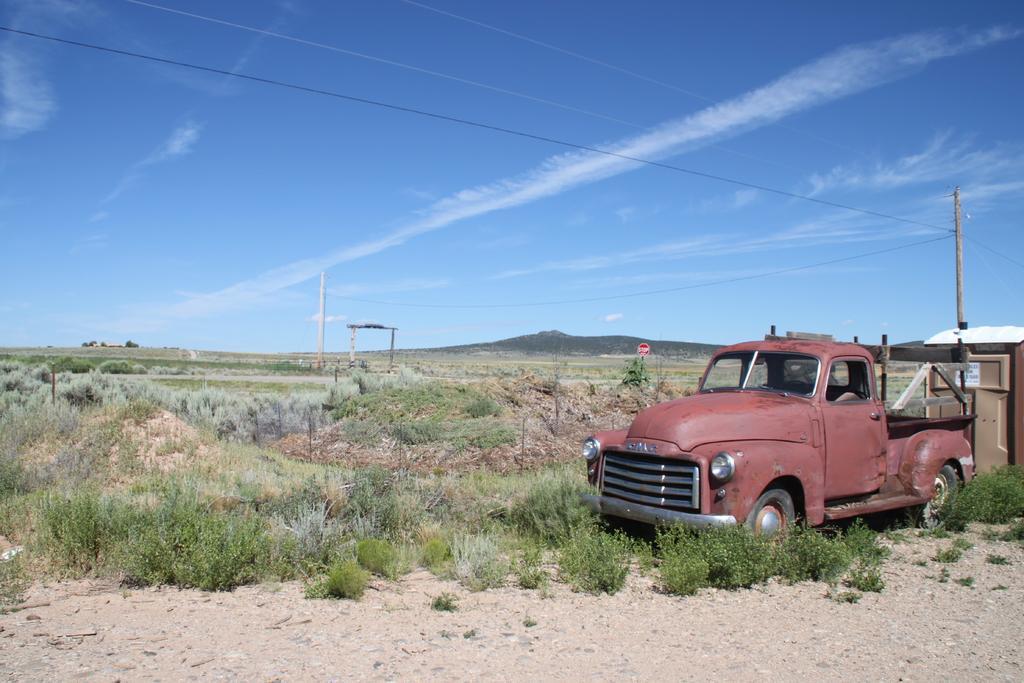In one or two sentences, can you explain what this image depicts? On the right side there is a building and car. Behind that there is a pole. On the ground there are grasses. In the background there is sky with clouds. 